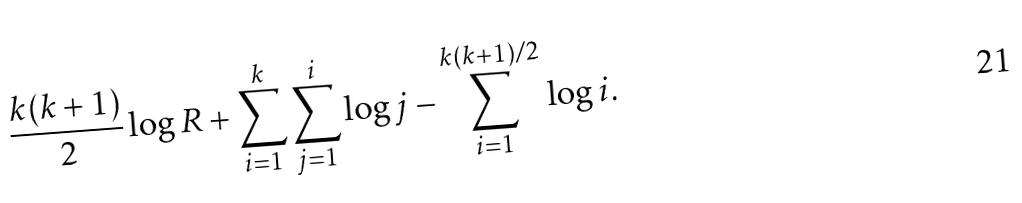Convert formula to latex. <formula><loc_0><loc_0><loc_500><loc_500>\frac { k ( k + 1 ) } { 2 } \log R + \sum _ { i = 1 } ^ { k } \sum _ { j = 1 } ^ { i } \log j - \sum _ { i = 1 } ^ { k ( k + 1 ) / 2 } \log i .</formula> 